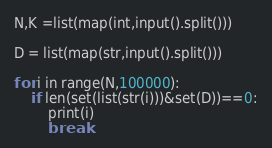<code> <loc_0><loc_0><loc_500><loc_500><_Python_>
N,K =list(map(int,input().split()))

D = list(map(str,input().split()))

for i in range(N,100000):
    if len(set(list(str(i)))&set(D))==0:
        print(i)
        break</code> 